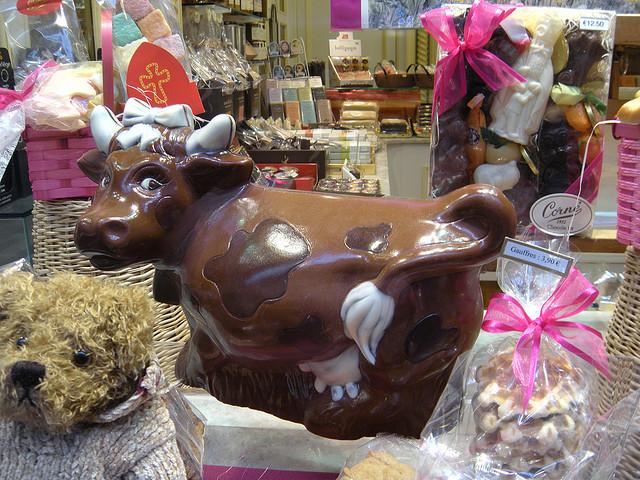Do you think this cow would cost over 5 dollars?
Write a very short answer. Yes. What color is the bow on the right?
Write a very short answer. Pink. Is the cow made of candy?
Be succinct. Yes. 